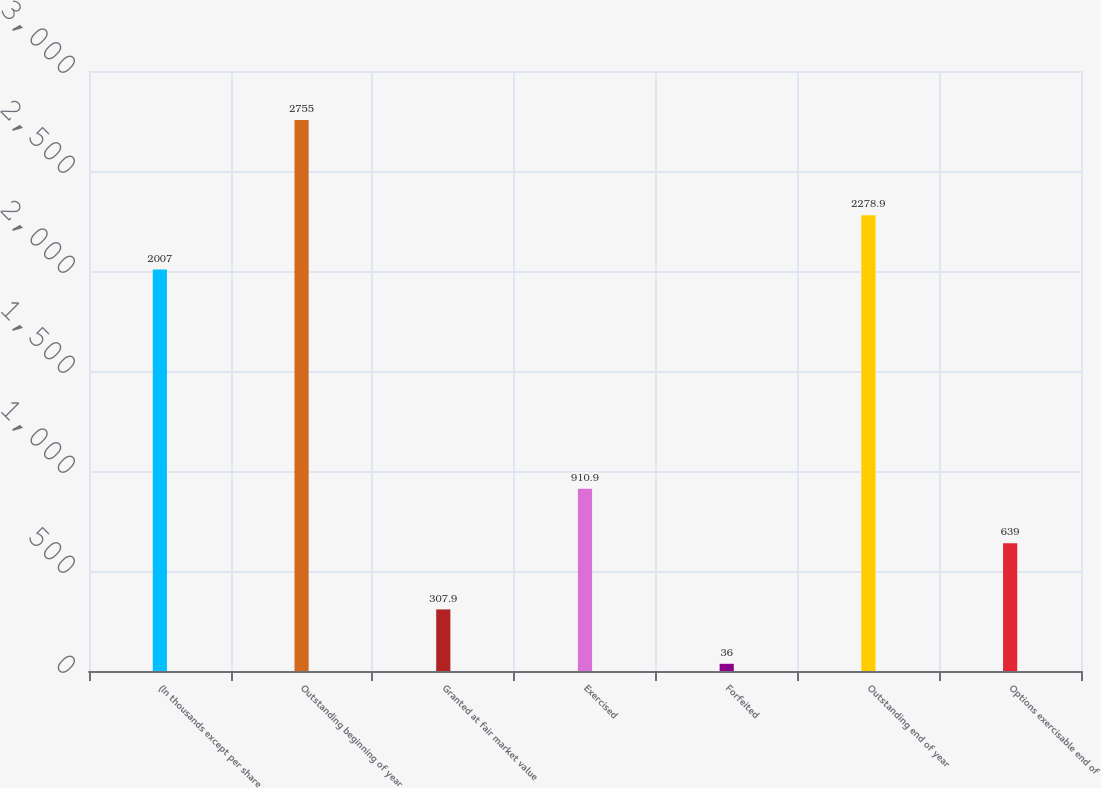<chart> <loc_0><loc_0><loc_500><loc_500><bar_chart><fcel>(In thousands except per share<fcel>Outstanding beginning of year<fcel>Granted at fair market value<fcel>Exercised<fcel>Forfeited<fcel>Outstanding end of year<fcel>Options exercisable end of<nl><fcel>2007<fcel>2755<fcel>307.9<fcel>910.9<fcel>36<fcel>2278.9<fcel>639<nl></chart> 